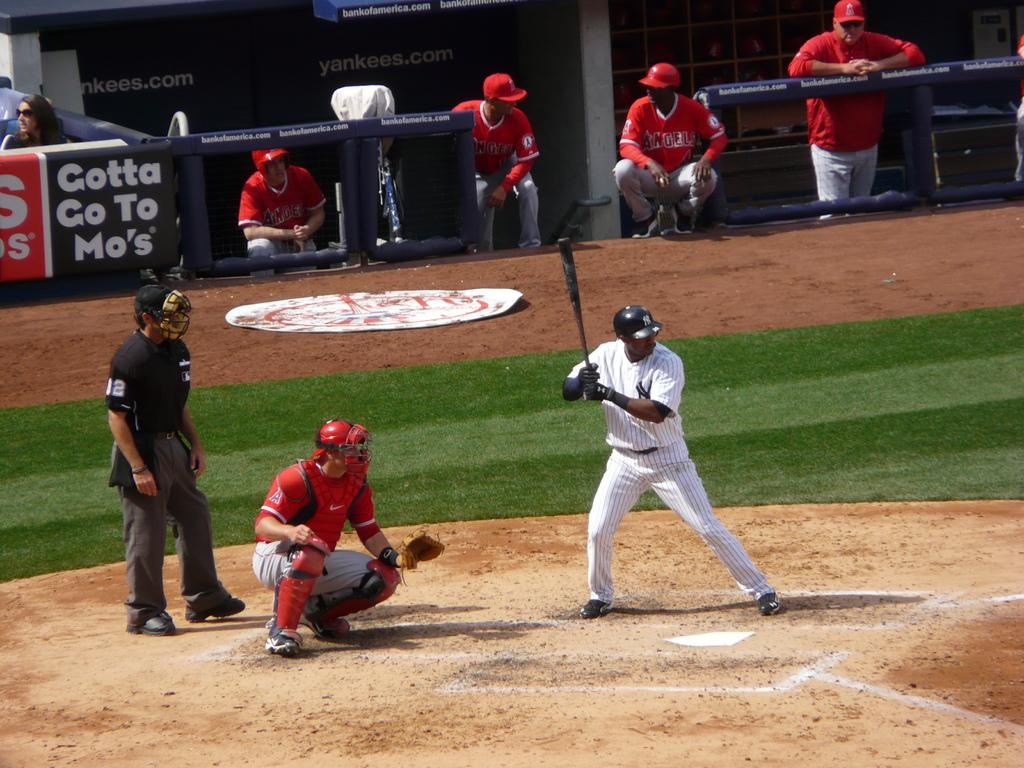<image>
Offer a succinct explanation of the picture presented. a player getting ready to hit with the word gotta behind him on the wall 